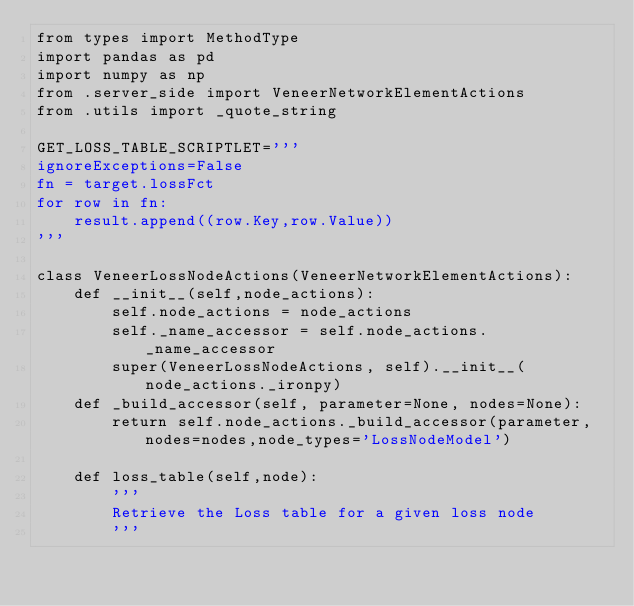<code> <loc_0><loc_0><loc_500><loc_500><_Python_>from types import MethodType
import pandas as pd
import numpy as np
from .server_side import VeneerNetworkElementActions
from .utils import _quote_string

GET_LOSS_TABLE_SCRIPTLET='''
ignoreExceptions=False
fn = target.lossFct
for row in fn:
    result.append((row.Key,row.Value))
'''

class VeneerLossNodeActions(VeneerNetworkElementActions):
    def __init__(self,node_actions):
        self.node_actions = node_actions
        self._name_accessor = self.node_actions._name_accessor
        super(VeneerLossNodeActions, self).__init__(node_actions._ironpy)
    def _build_accessor(self, parameter=None, nodes=None):
        return self.node_actions._build_accessor(parameter,nodes=nodes,node_types='LossNodeModel')

    def loss_table(self,node):
        '''
        Retrieve the Loss table for a given loss node
        '''</code> 